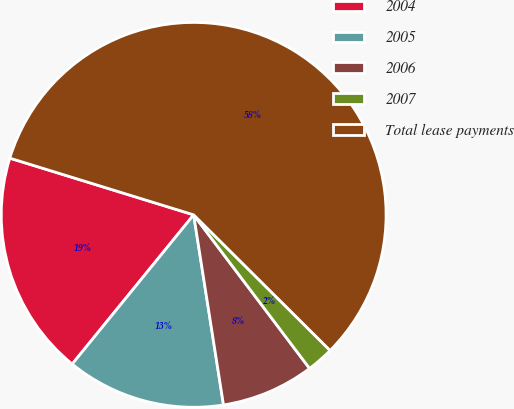<chart> <loc_0><loc_0><loc_500><loc_500><pie_chart><fcel>2004<fcel>2005<fcel>2006<fcel>2007<fcel>Total lease payments<nl><fcel>18.89%<fcel>13.35%<fcel>7.81%<fcel>2.26%<fcel>57.69%<nl></chart> 